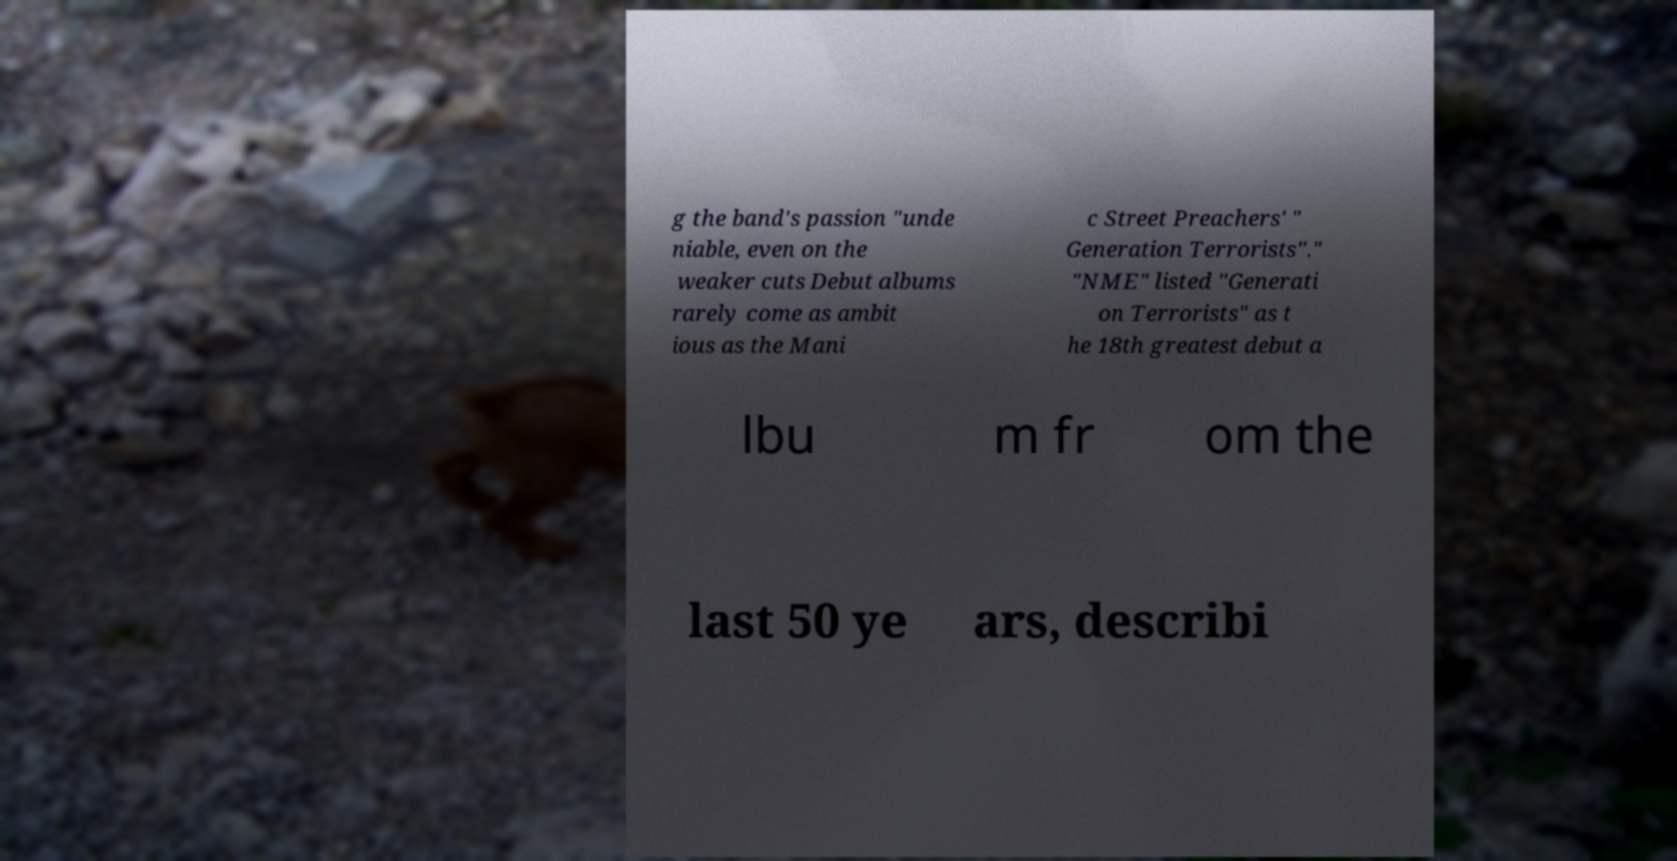I need the written content from this picture converted into text. Can you do that? g the band's passion "unde niable, even on the weaker cuts Debut albums rarely come as ambit ious as the Mani c Street Preachers' " Generation Terrorists"." "NME" listed "Generati on Terrorists" as t he 18th greatest debut a lbu m fr om the last 50 ye ars, describi 